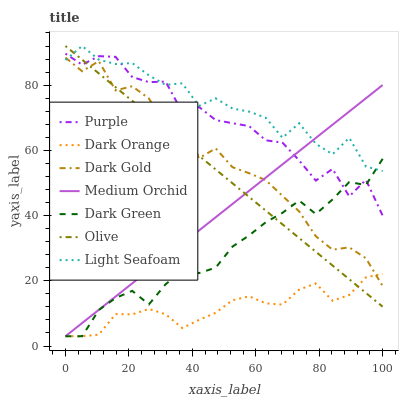Does Dark Orange have the minimum area under the curve?
Answer yes or no. Yes. Does Light Seafoam have the maximum area under the curve?
Answer yes or no. Yes. Does Dark Gold have the minimum area under the curve?
Answer yes or no. No. Does Dark Gold have the maximum area under the curve?
Answer yes or no. No. Is Olive the smoothest?
Answer yes or no. Yes. Is Purple the roughest?
Answer yes or no. Yes. Is Dark Gold the smoothest?
Answer yes or no. No. Is Dark Gold the roughest?
Answer yes or no. No. Does Dark Orange have the lowest value?
Answer yes or no. Yes. Does Dark Gold have the lowest value?
Answer yes or no. No. Does Light Seafoam have the highest value?
Answer yes or no. Yes. Does Dark Gold have the highest value?
Answer yes or no. No. Is Dark Orange less than Purple?
Answer yes or no. Yes. Is Light Seafoam greater than Dark Orange?
Answer yes or no. Yes. Does Olive intersect Light Seafoam?
Answer yes or no. Yes. Is Olive less than Light Seafoam?
Answer yes or no. No. Is Olive greater than Light Seafoam?
Answer yes or no. No. Does Dark Orange intersect Purple?
Answer yes or no. No. 